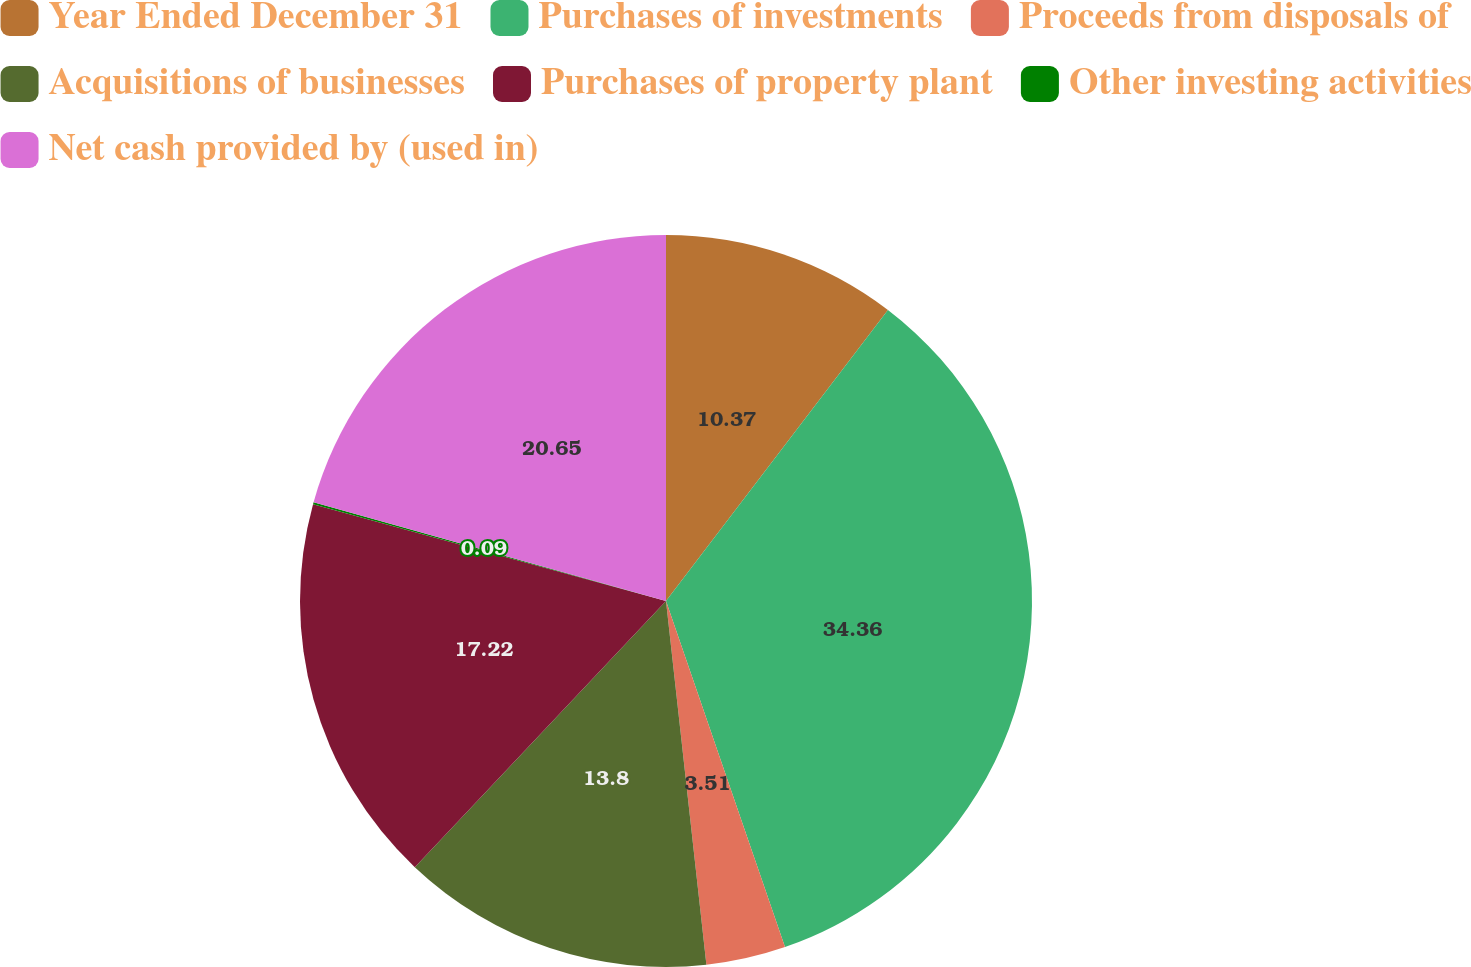Convert chart. <chart><loc_0><loc_0><loc_500><loc_500><pie_chart><fcel>Year Ended December 31<fcel>Purchases of investments<fcel>Proceeds from disposals of<fcel>Acquisitions of businesses<fcel>Purchases of property plant<fcel>Other investing activities<fcel>Net cash provided by (used in)<nl><fcel>10.37%<fcel>34.36%<fcel>3.51%<fcel>13.8%<fcel>17.22%<fcel>0.09%<fcel>20.65%<nl></chart> 